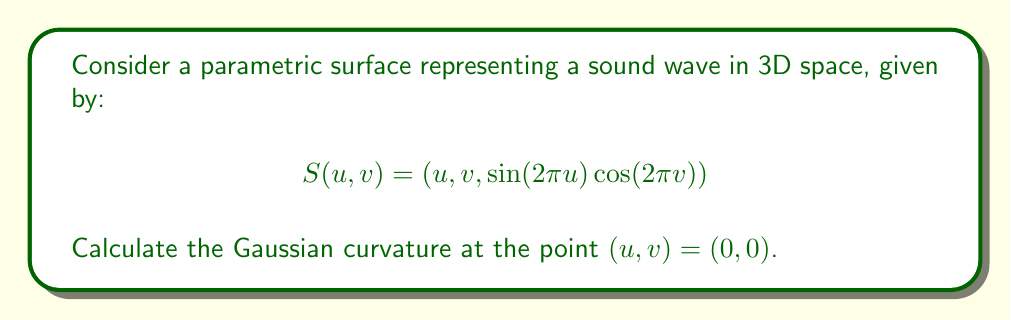Provide a solution to this math problem. To calculate the Gaussian curvature of a parametric surface, we need to follow these steps:

1. Calculate the first fundamental form coefficients (E, F, G):
   $$S_u = (1, 0, 2\pi \cos(2\pi u) \cos(2\pi v))$$
   $$S_v = (0, 1, -2\pi \sin(2\pi u) \sin(2\pi v))$$
   
   At $(0,0)$:
   $$E = S_u \cdot S_u = 1 + 4\pi^2 = 1 + 4\pi^2$$
   $$F = S_u \cdot S_v = 0$$
   $$G = S_v \cdot S_v = 1$$

2. Calculate the second fundamental form coefficients (L, M, N):
   $$S_{uu} = (0, 0, -4\pi^2 \sin(2\pi u) \cos(2\pi v))$$
   $$S_{uv} = (0, 0, -4\pi^2 \cos(2\pi u) \sin(2\pi v))$$
   $$S_{vv} = (0, 0, -4\pi^2 \sin(2\pi u) \cos(2\pi v))$$
   
   Normal vector:
   $$N = \frac{S_u \times S_v}{|S_u \times S_v|} = \frac{(-2\pi \cos(2\pi u) \cos(2\pi v), 2\pi \sin(2\pi u) \sin(2\pi v), 1)}{\sqrt{1 + 4\pi^2}}$$
   
   At $(0,0)$:
   $$L = S_{uu} \cdot N = \frac{-4\pi^2}{\sqrt{1 + 4\pi^2}}$$
   $$M = S_{uv} \cdot N = 0$$
   $$N = S_{vv} \cdot N = \frac{-4\pi^2}{\sqrt{1 + 4\pi^2}}$$

3. Calculate the Gaussian curvature:
   $$K = \frac{LN - M^2}{EG - F^2}$$

   Substituting the values:
   $$K = \frac{(\frac{-4\pi^2}{\sqrt{1 + 4\pi^2}})(\frac{-4\pi^2}{\sqrt{1 + 4\pi^2}}) - 0^2}{(1 + 4\pi^2)(1) - 0^2}$$
   
   $$K = \frac{16\pi^4}{(1 + 4\pi^2)^2}$$
Answer: $K = \frac{16\pi^4}{(1 + 4\pi^2)^2}$ 